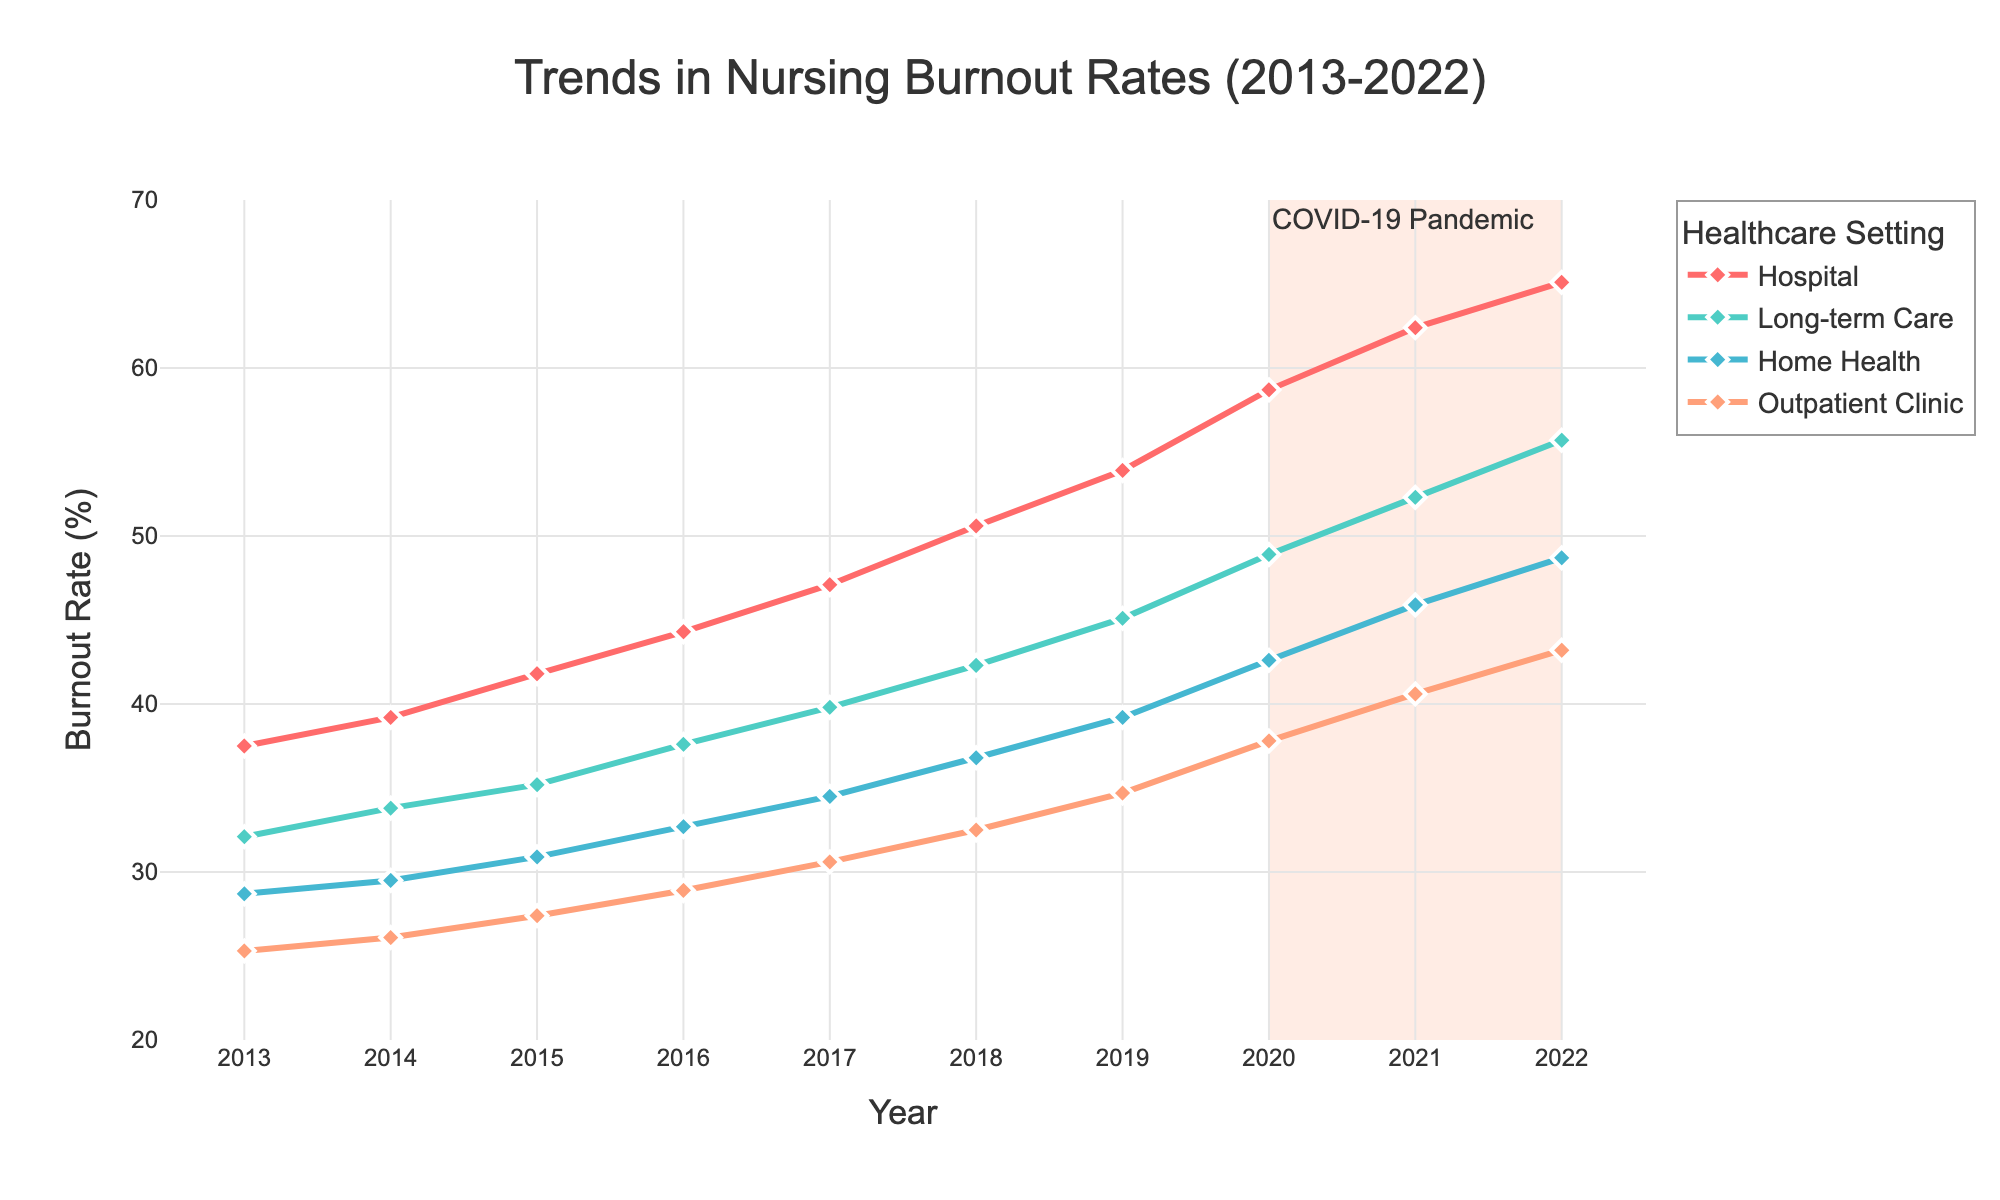Which healthcare setting had the highest burnout rate in 2022? Look at the end of each line on the right-hand side of the chart for the year 2022. The highest point is associated with the 'Hospital' line.
Answer: Hospital How did the burnout rate in Home Health settings change from 2013 to 2016? Observe the points associated with Home Health from 2013 to 2016. The rate increased from 28.7% to 32.7%.
Answer: Increased Which two settings had the smallest difference in burnout rates in 2019? Compare the rates for each setting in 2019. The smallest difference is between Home Health (39.2%) and Outpatient Clinic (34.7%), a difference of 4.5%.
Answer: Home Health and Outpatient Clinic What is the average burnout rate for Long-term Care settings over the decade? Sum the rates for each year (32.1 + 33.8 + 35.2 + 37.6 + 39.8 + 42.3 + 45.1 + 48.9 + 52.3 + 55.7) and divide by 10. The sum is 423.8, so the average is 423.8 / 10 = 42.38%.
Answer: 42.38% Which healthcare setting showed the most significant increase during the COVID-19 pandemic period (2020-2022)? Compare the increments for each setting from 2020 to 2022. The Hospital setting increased from 58.7% to 65.1%, an increase of 6.4%, which is the highest.
Answer: Hospital In which year did the burnout rate for Outpatient Clinics first exceed 30%? Follow the Outpatient Clinic line until it surpasses 30%. It first surpasses 30% in 2017.
Answer: 2017 By how much did the burnout rates for Long-term Care nurses increase between 2015 and 2018? The rate in 2015 is 35.2%, and in 2018 it is 42.3%. The increase is 42.3% - 35.2% = 7.1%.
Answer: 7.1% Which setting had the most stable burnout rate trend over the past decade? Look at each line's fluctuation. Outpatient Clinics had the most gradual and stable increase in comparison to other settings.
Answer: Outpatient Clinic What was the total increase in burnout rate for Hospital settings from 2013 to 2022? The rate in 2013 is 37.5%, and in 2022 it is 65.1%. The total increase is 65.1% - 37.5% = 27.6%.
Answer: 27.6% During which years did Home Health show a continuous increase in burnout rate without any declines? Home Health burnout rate consistently increased every year from 2013 to 2022 without any declines.
Answer: 2013-2022 